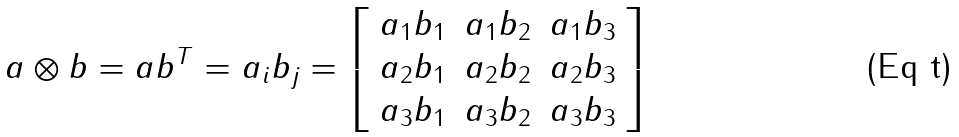Convert formula to latex. <formula><loc_0><loc_0><loc_500><loc_500>a \otimes b = a b ^ { T } = a _ { i } b _ { j } = \left [ \begin{array} { c c c } a _ { 1 } b _ { 1 } & a _ { 1 } b _ { 2 } & a _ { 1 } b _ { 3 } \\ a _ { 2 } b _ { 1 } & a _ { 2 } b _ { 2 } & a _ { 2 } b _ { 3 } \\ a _ { 3 } b _ { 1 } & a _ { 3 } b _ { 2 } & a _ { 3 } b _ { 3 } \end{array} \right ]</formula> 